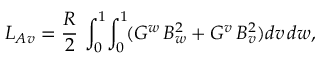Convert formula to latex. <formula><loc_0><loc_0><loc_500><loc_500>L _ { A v } = \frac { R } { 2 } \, \int _ { 0 } ^ { 1 } \, \int _ { 0 } ^ { 1 } \, ( G ^ { w } \, B _ { w } ^ { 2 } + G ^ { v } \, B _ { v } ^ { 2 } ) d v \, d w ,</formula> 